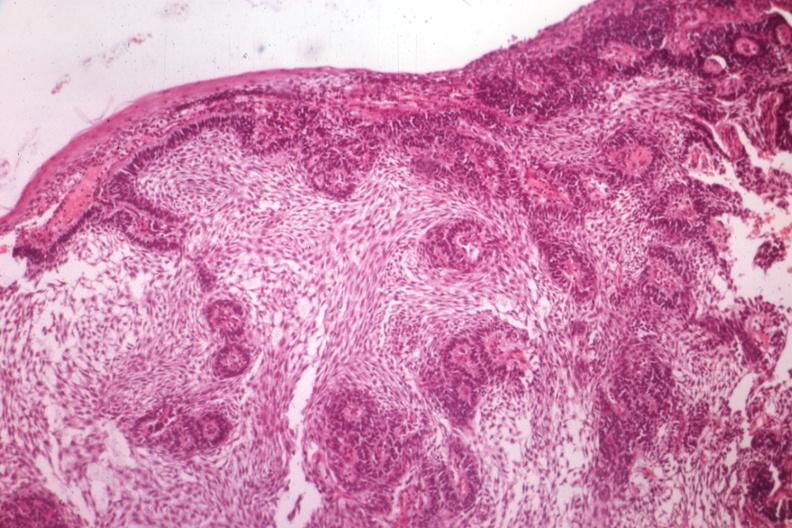what is present?
Answer the question using a single word or phrase. Bone 